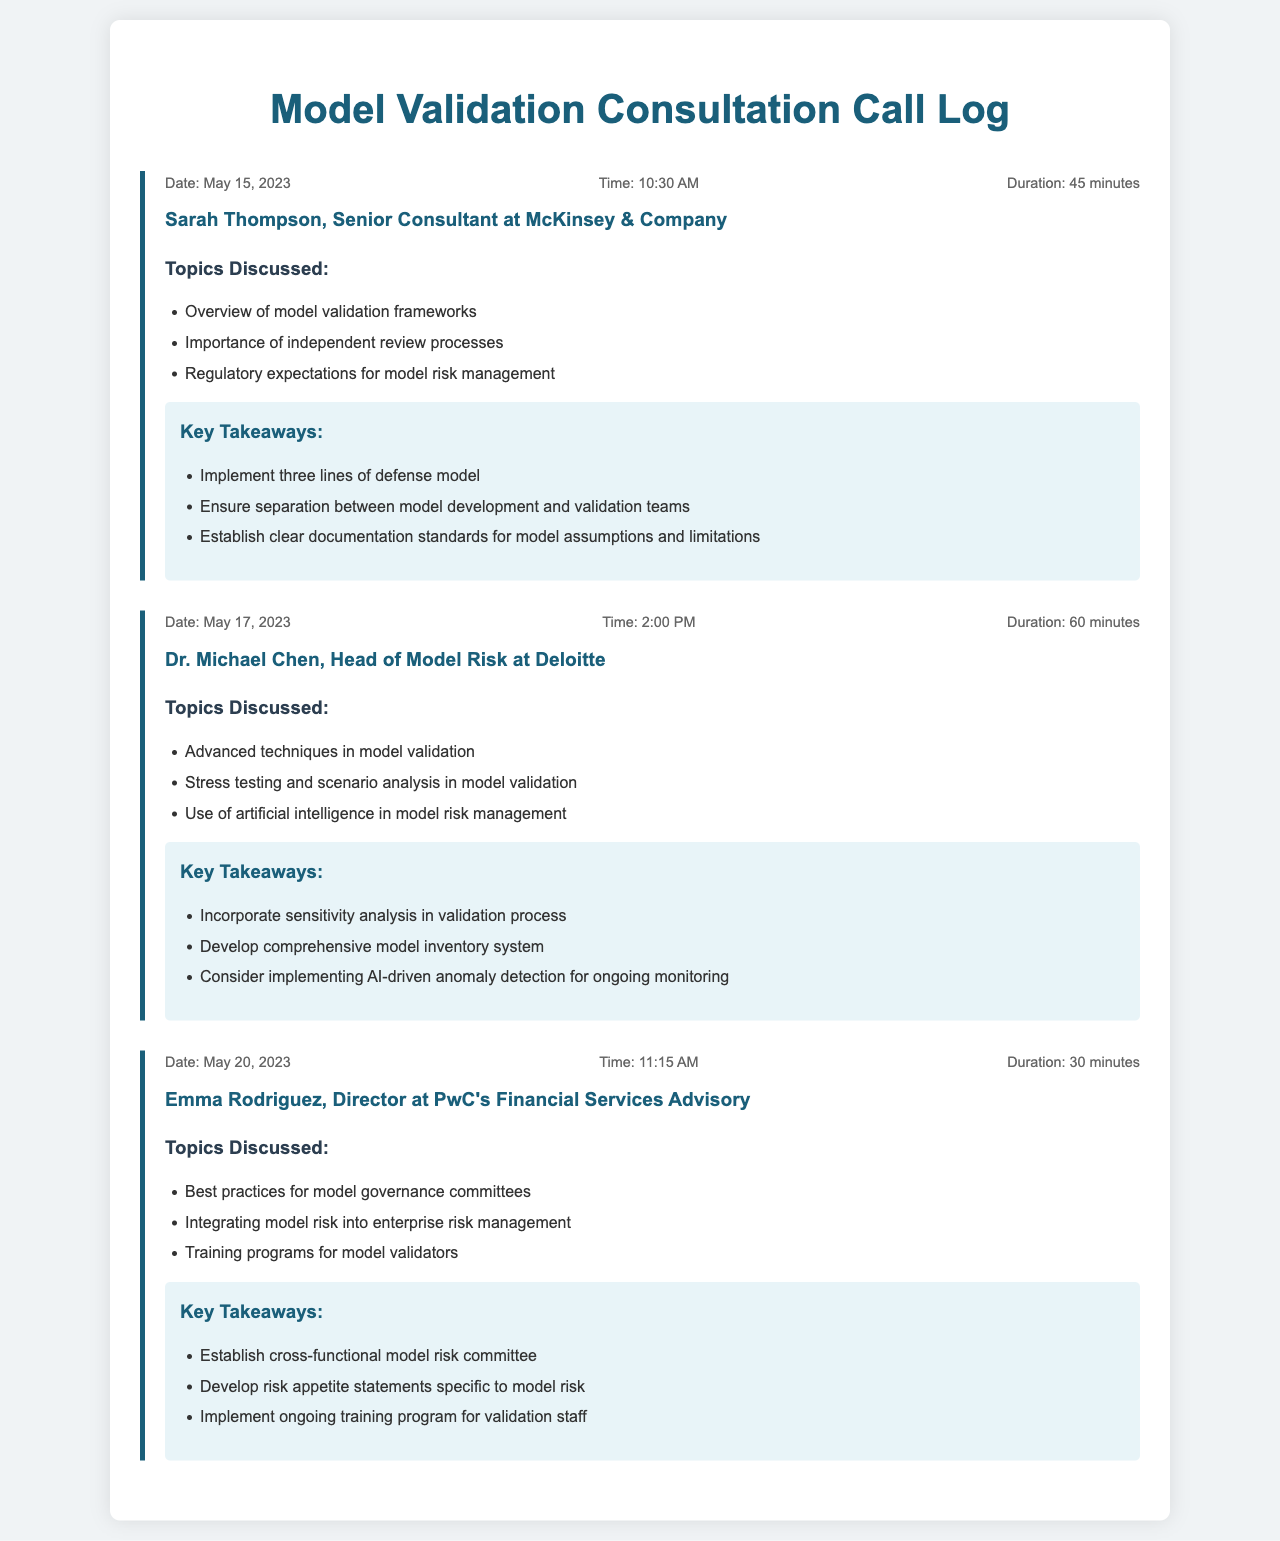What is the date of the first call? The date of the first call is stated in the document under the first call log section.
Answer: May 15, 2023 Who was the consultant in the last call? The consultant's name is mentioned in the call log section of the last call.
Answer: Emma Rodriguez What was the duration of the second call? The duration can be found in the call info of the second call log.
Answer: 60 minutes What is one key takeaway from the third call? The key takeaways are listed in the key takeaways section of the third call log.
Answer: Establish cross-functional model risk committee How many calls are detailed in the document? The number of calls can be counted by looking at the call log sections provided in the document.
Answer: Three Which organization did Sarah Thompson represent? The organization represented by Sarah Thompson is mentioned in the contact section of the first call log.
Answer: McKinsey & Company What is the main topic discussed in the second call? The main topics are listed in the topics discussed section of the second call log.
Answer: Advanced techniques in model validation What is a suggested practice for model documentation mentioned in the first call? Suggested practices are listed in the key takeaways section of the first call log.
Answer: Establish clear documentation standards for model assumptions and limitations What topic was discussed related to artificial intelligence? The topic is specified under the topics discussed section of the second call log.
Answer: Use of artificial intelligence in model risk management 